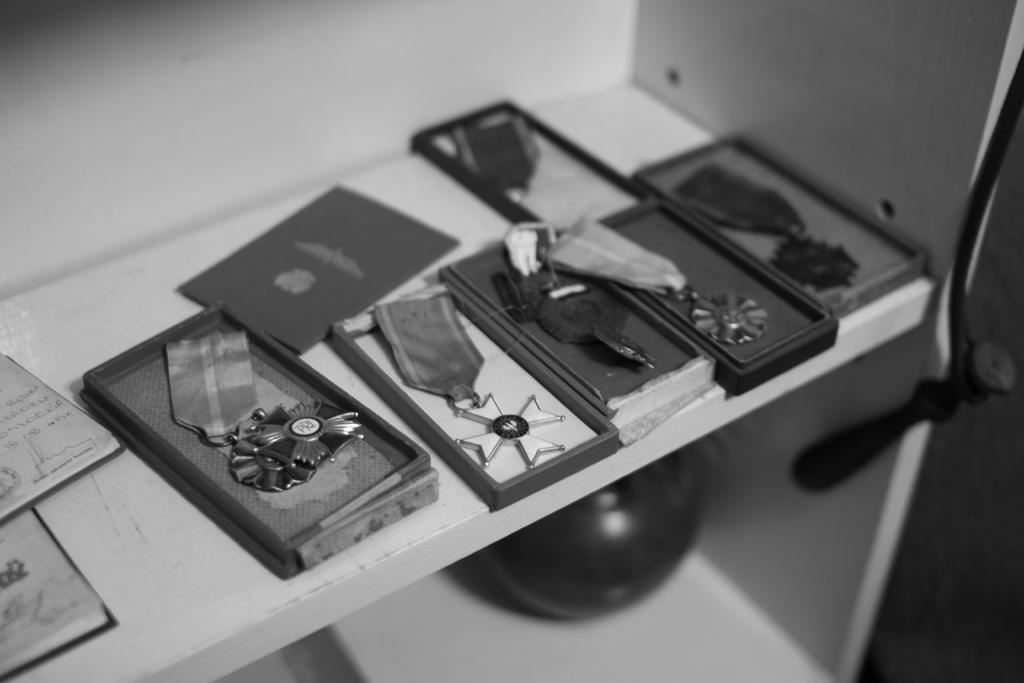What can be seen in the image related to badges? There are different types of badges in the image. How many badges are there in total? There are six badges in total. How are the badges arranged in the image? The badges are placed in six boxes on a shelf. What is the color scheme of the image? The image is black and white. What type of noise can be heard coming from the badges in the image? There is no noise coming from the badges in the image, as badges are inanimate objects and do not produce sound. 